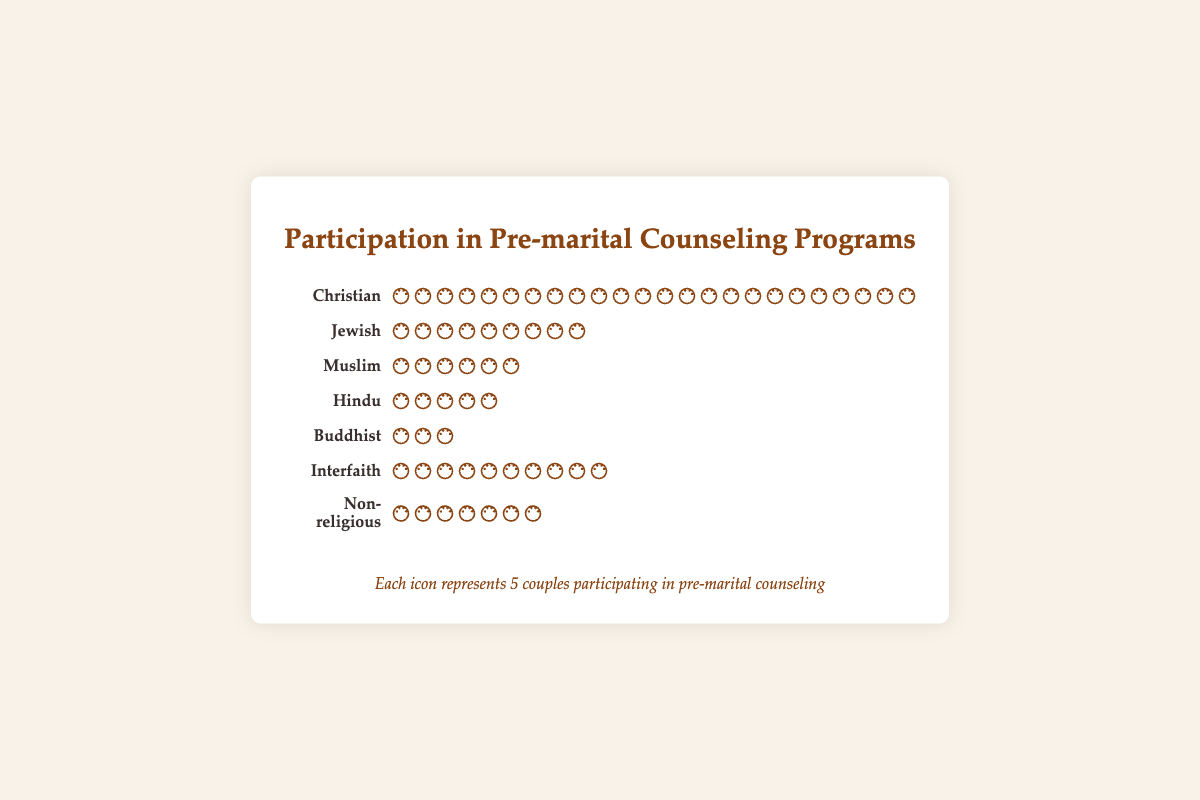How many couples from the Christian background participated in the pre-marital counseling programs? The figure shows that there are 24 icons representing Christian couples, with each icon representing 5 couples. Multiplying 24 icons by 5 gives you 120 couples.
Answer: 120 Which religious background has the least number of couples participating in the counseling programs? By observing the number of icons, the Buddhist background has the least number, with only 3 icons. Each icon representing 5 couples means 3 multiplied by 5 equals 15 couples.
Answer: Buddhist How many more couples from the Christian background participated compared to the Muslim background? The Christian background has 24 icons (120 couples) while the Muslim background has 6 icons (30 couples). Subtracting the Muslim count from the Christian count gives 120 - 30 = 90.
Answer: 90 What is the total number of couples from Interfaith and Non-religious backgrounds? Interfaith has 10 icons (50 couples) and Non-religious has 7 icons (35 couples). Adding them together gives 50 + 35 = 85 couples.
Answer: 85 Compare the participation in pre-marital counseling between Jewish and Hindu couples. Which group has more participants and by how many? Jewish couples have 9 icons (45 couples) while Hindu couples have 5 icons (25 couples). Subtracting the count of Hindu couples from Jewish couples gives 45 - 25 = 20.
Answer: Jewish by 20 What is the sum of all participating couples in the figure? Summing all the couples: Christian (120) + Jewish (45) + Muslim (30) + Hindu (25) + Buddhist (15) + Interfaith (50) + Non-religious (35) gives a total of 320.
Answer: 320 Which two religious backgrounds have the same number of icons, thus the same number of participating couples? By counting the icons for each background, Hindu and Muslim backgrounds both have 5 icons each. Therefore, both have the same participation of 25 couples.
Answer: Hindu and Muslim 